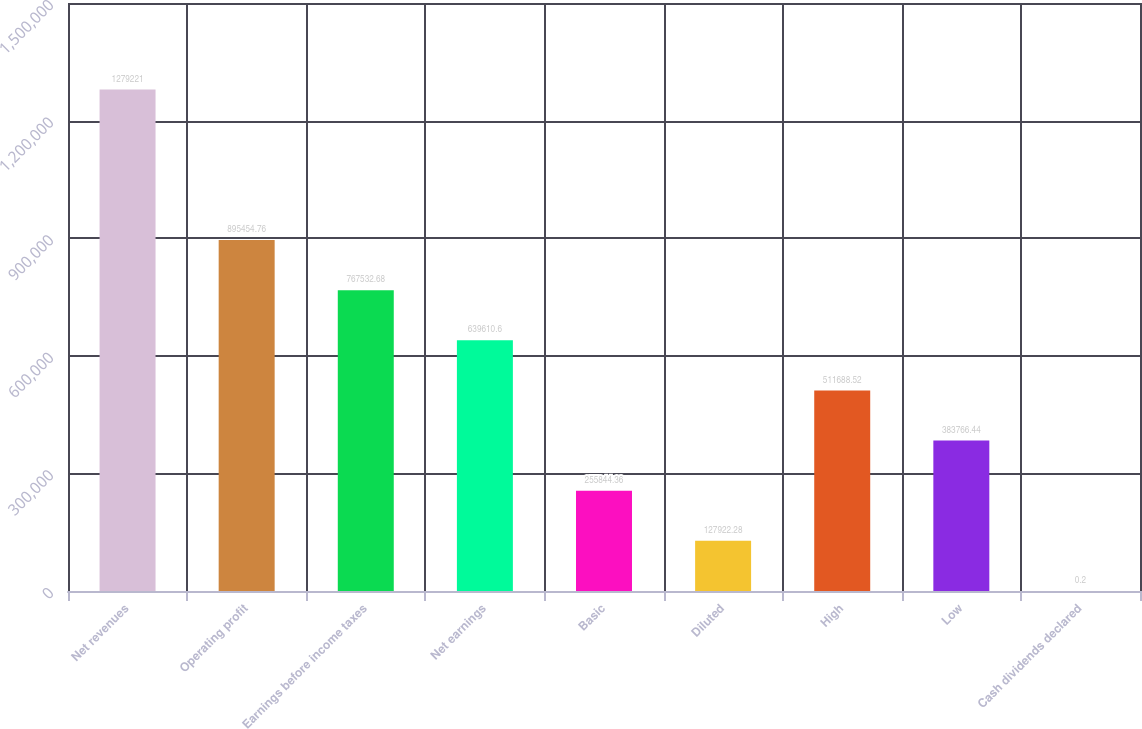<chart> <loc_0><loc_0><loc_500><loc_500><bar_chart><fcel>Net revenues<fcel>Operating profit<fcel>Earnings before income taxes<fcel>Net earnings<fcel>Basic<fcel>Diluted<fcel>High<fcel>Low<fcel>Cash dividends declared<nl><fcel>1.27922e+06<fcel>895455<fcel>767533<fcel>639611<fcel>255844<fcel>127922<fcel>511689<fcel>383766<fcel>0.2<nl></chart> 